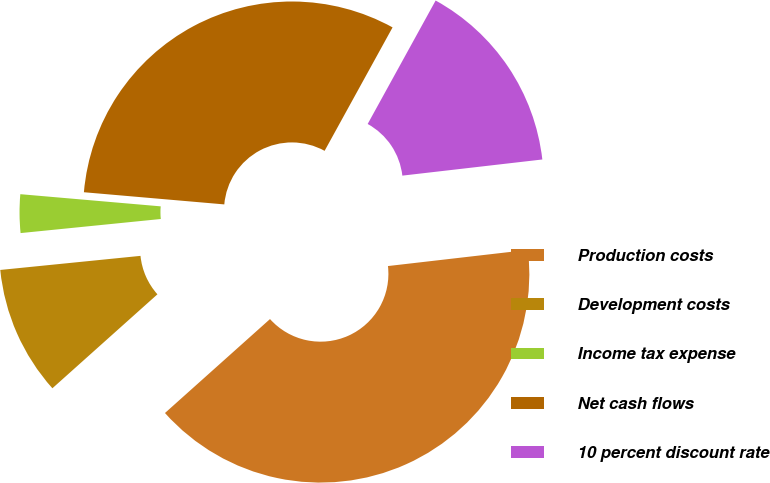Convert chart. <chart><loc_0><loc_0><loc_500><loc_500><pie_chart><fcel>Production costs<fcel>Development costs<fcel>Income tax expense<fcel>Net cash flows<fcel>10 percent discount rate<nl><fcel>40.21%<fcel>10.02%<fcel>2.97%<fcel>31.63%<fcel>15.16%<nl></chart> 